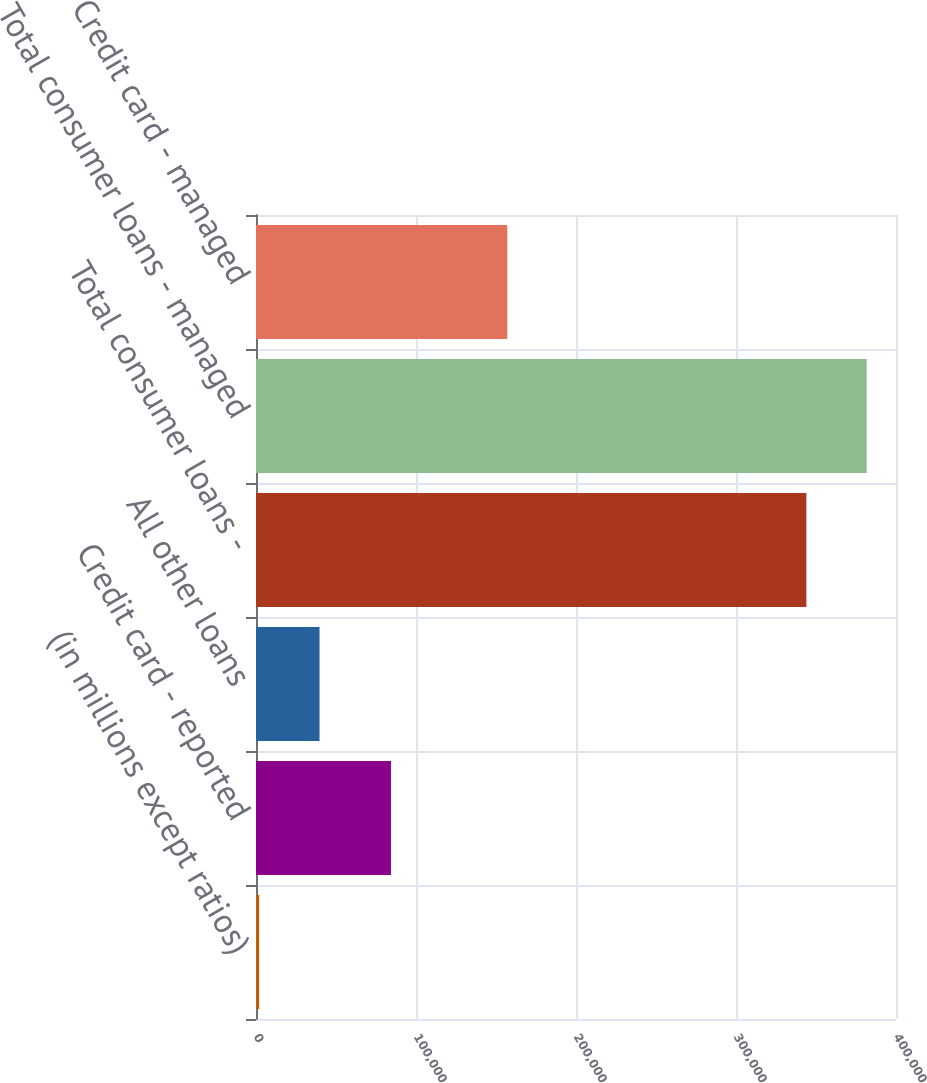Convert chart. <chart><loc_0><loc_0><loc_500><loc_500><bar_chart><fcel>(in millions except ratios)<fcel>Credit card - reported<fcel>All other loans<fcel>Total consumer loans -<fcel>Total consumer loans - managed<fcel>Memo Credit card - managed<nl><fcel>2007<fcel>84352<fcel>39706.2<fcel>343997<fcel>381696<fcel>157053<nl></chart> 